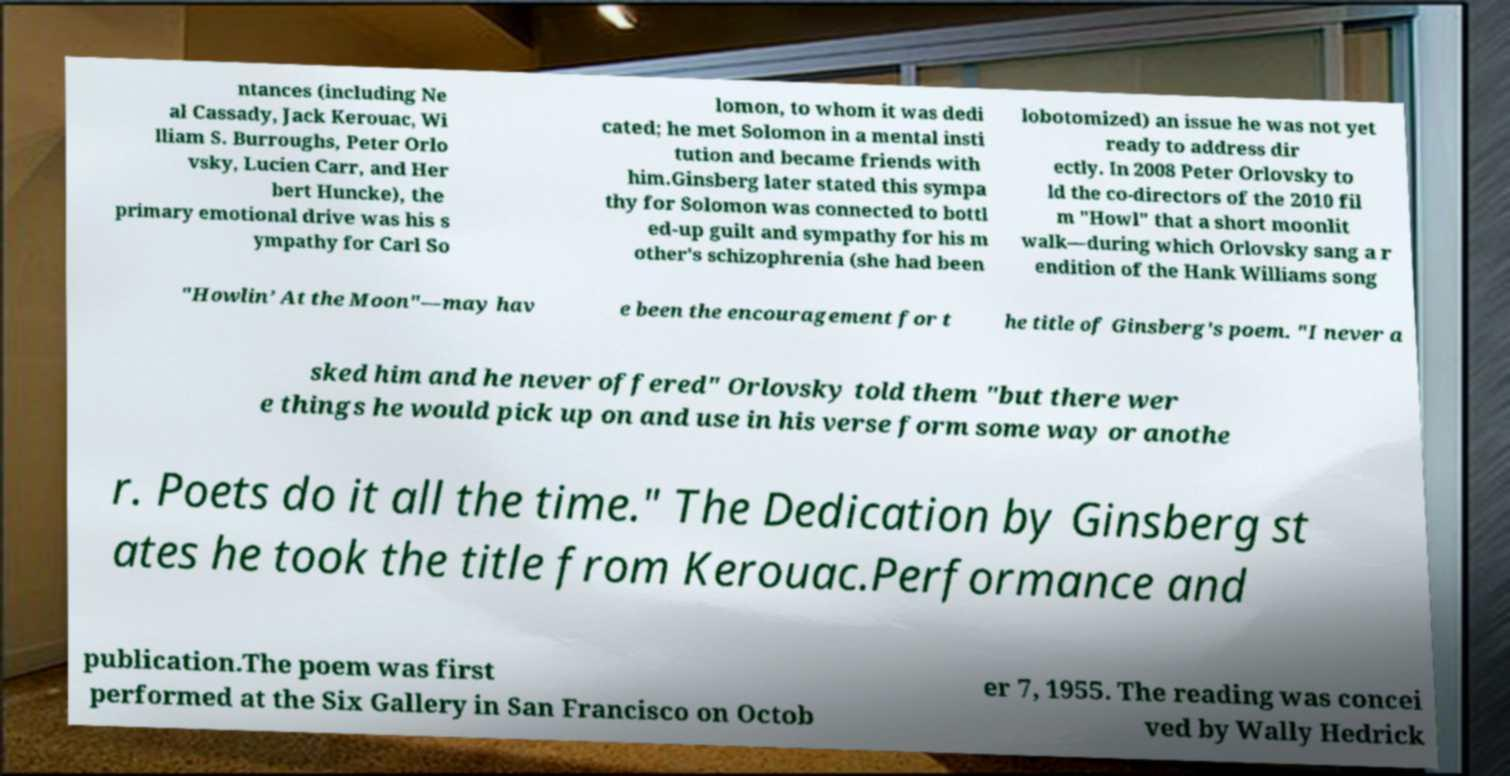Could you assist in decoding the text presented in this image and type it out clearly? ntances (including Ne al Cassady, Jack Kerouac, Wi lliam S. Burroughs, Peter Orlo vsky, Lucien Carr, and Her bert Huncke), the primary emotional drive was his s ympathy for Carl So lomon, to whom it was dedi cated; he met Solomon in a mental insti tution and became friends with him.Ginsberg later stated this sympa thy for Solomon was connected to bottl ed-up guilt and sympathy for his m other's schizophrenia (she had been lobotomized) an issue he was not yet ready to address dir ectly. In 2008 Peter Orlovsky to ld the co-directors of the 2010 fil m "Howl" that a short moonlit walk—during which Orlovsky sang a r endition of the Hank Williams song "Howlin’ At the Moon"—may hav e been the encouragement for t he title of Ginsberg's poem. "I never a sked him and he never offered" Orlovsky told them "but there wer e things he would pick up on and use in his verse form some way or anothe r. Poets do it all the time." The Dedication by Ginsberg st ates he took the title from Kerouac.Performance and publication.The poem was first performed at the Six Gallery in San Francisco on Octob er 7, 1955. The reading was concei ved by Wally Hedrick 